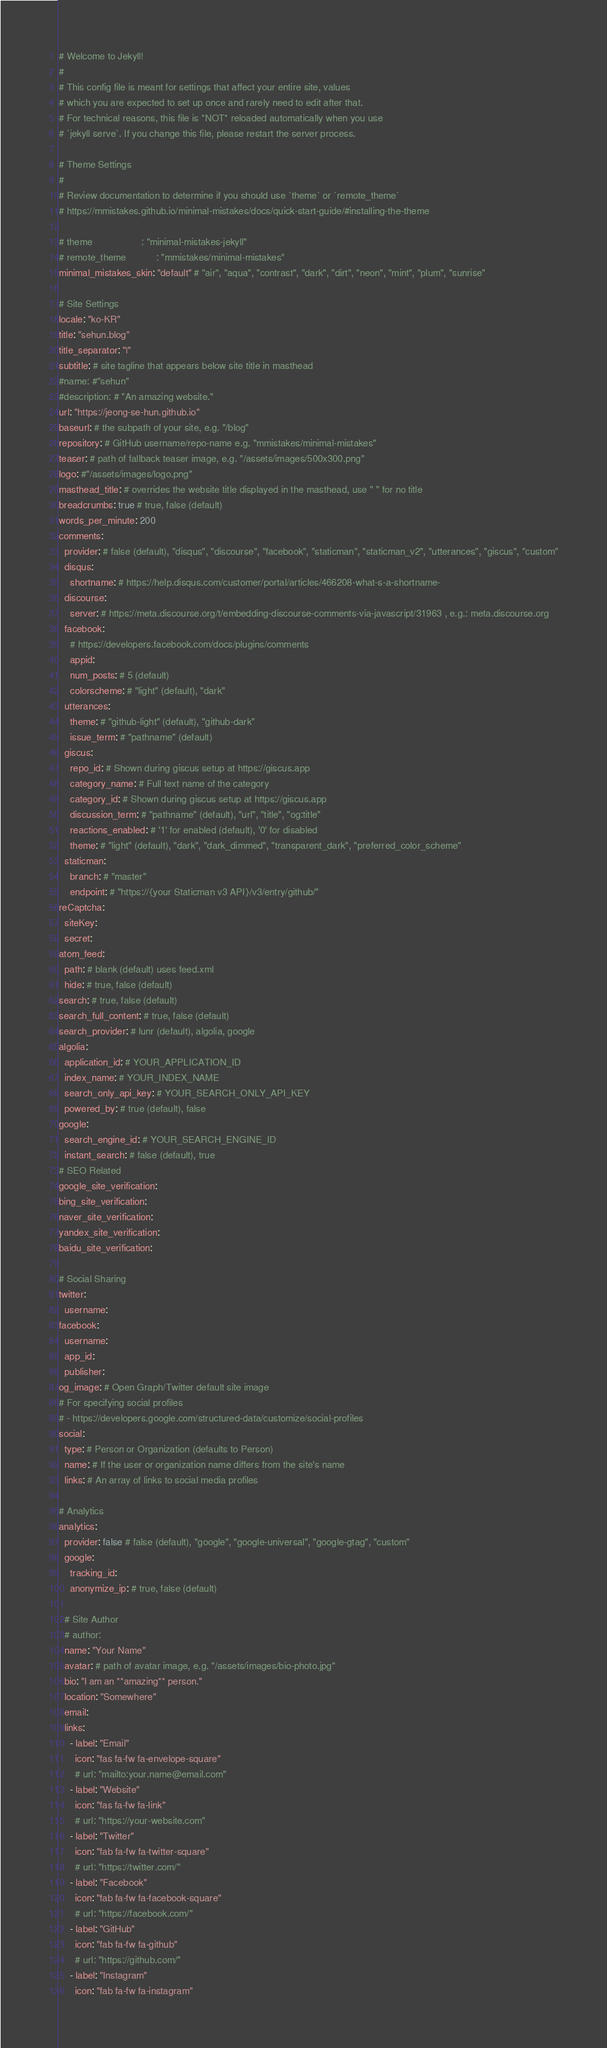Convert code to text. <code><loc_0><loc_0><loc_500><loc_500><_YAML_># Welcome to Jekyll!
#
# This config file is meant for settings that affect your entire site, values
# which you are expected to set up once and rarely need to edit after that.
# For technical reasons, this file is *NOT* reloaded automatically when you use
# `jekyll serve`. If you change this file, please restart the server process.

# Theme Settings
#
# Review documentation to determine if you should use `theme` or `remote_theme`
# https://mmistakes.github.io/minimal-mistakes/docs/quick-start-guide/#installing-the-theme

# theme                  : "minimal-mistakes-jekyll"
# remote_theme           : "mmistakes/minimal-mistakes"
minimal_mistakes_skin: "default" # "air", "aqua", "contrast", "dark", "dirt", "neon", "mint", "plum", "sunrise"

# Site Settings
locale: "ko-KR"
title: "sehun.blog"
title_separator: "|"
subtitle: # site tagline that appears below site title in masthead
#name: #"sehun"
#description: # "An amazing website."
url: "https://jeong-se-hun.github.io"
baseurl: # the subpath of your site, e.g. "/blog"
repository: # GitHub username/repo-name e.g. "mmistakes/minimal-mistakes"
teaser: # path of fallback teaser image, e.g. "/assets/images/500x300.png"
logo: #"/assets/images/logo.png"
masthead_title: # overrides the website title displayed in the masthead, use " " for no title
breadcrumbs: true # true, false (default)
words_per_minute: 200
comments:
  provider: # false (default), "disqus", "discourse", "facebook", "staticman", "staticman_v2", "utterances", "giscus", "custom"
  disqus:
    shortname: # https://help.disqus.com/customer/portal/articles/466208-what-s-a-shortname-
  discourse:
    server: # https://meta.discourse.org/t/embedding-discourse-comments-via-javascript/31963 , e.g.: meta.discourse.org
  facebook:
    # https://developers.facebook.com/docs/plugins/comments
    appid:
    num_posts: # 5 (default)
    colorscheme: # "light" (default), "dark"
  utterances:
    theme: # "github-light" (default), "github-dark"
    issue_term: # "pathname" (default)
  giscus:
    repo_id: # Shown during giscus setup at https://giscus.app
    category_name: # Full text name of the category
    category_id: # Shown during giscus setup at https://giscus.app
    discussion_term: # "pathname" (default), "url", "title", "og:title"
    reactions_enabled: # '1' for enabled (default), '0' for disabled
    theme: # "light" (default), "dark", "dark_dimmed", "transparent_dark", "preferred_color_scheme"
  staticman:
    branch: # "master"
    endpoint: # "https://{your Staticman v3 API}/v3/entry/github/"
reCaptcha:
  siteKey:
  secret:
atom_feed:
  path: # blank (default) uses feed.xml
  hide: # true, false (default)
search: # true, false (default)
search_full_content: # true, false (default)
search_provider: # lunr (default), algolia, google
algolia:
  application_id: # YOUR_APPLICATION_ID
  index_name: # YOUR_INDEX_NAME
  search_only_api_key: # YOUR_SEARCH_ONLY_API_KEY
  powered_by: # true (default), false
google:
  search_engine_id: # YOUR_SEARCH_ENGINE_ID
  instant_search: # false (default), true
# SEO Related
google_site_verification:
bing_site_verification:
naver_site_verification:
yandex_site_verification:
baidu_site_verification:

# Social Sharing
twitter:
  username:
facebook:
  username:
  app_id:
  publisher:
og_image: # Open Graph/Twitter default site image
# For specifying social profiles
# - https://developers.google.com/structured-data/customize/social-profiles
social:
  type: # Person or Organization (defaults to Person)
  name: # If the user or organization name differs from the site's name
  links: # An array of links to social media profiles

# Analytics
analytics:
  provider: false # false (default), "google", "google-universal", "google-gtag", "custom"
  google:
    tracking_id:
    anonymize_ip: # true, false (default)

  # Site Author
  # author:
  name: "Your Name"
  avatar: # path of avatar image, e.g. "/assets/images/bio-photo.jpg"
  bio: "I am an **amazing** person."
  location: "Somewhere"
  email:
  links:
    - label: "Email"
      icon: "fas fa-fw fa-envelope-square"
      # url: "mailto:your.name@email.com"
    - label: "Website"
      icon: "fas fa-fw fa-link"
      # url: "https://your-website.com"
    - label: "Twitter"
      icon: "fab fa-fw fa-twitter-square"
      # url: "https://twitter.com/"
    - label: "Facebook"
      icon: "fab fa-fw fa-facebook-square"
      # url: "https://facebook.com/"
    - label: "GitHub"
      icon: "fab fa-fw fa-github"
      # url: "https://github.com/"
    - label: "Instagram"
      icon: "fab fa-fw fa-instagram"</code> 